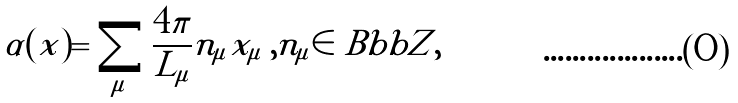Convert formula to latex. <formula><loc_0><loc_0><loc_500><loc_500>\alpha ( x ) = \sum _ { \mu } \frac { 4 \pi } { L _ { \mu } } n _ { \mu } x _ { \mu } \, , n _ { \mu } \in { \ B b b Z } ,</formula> 